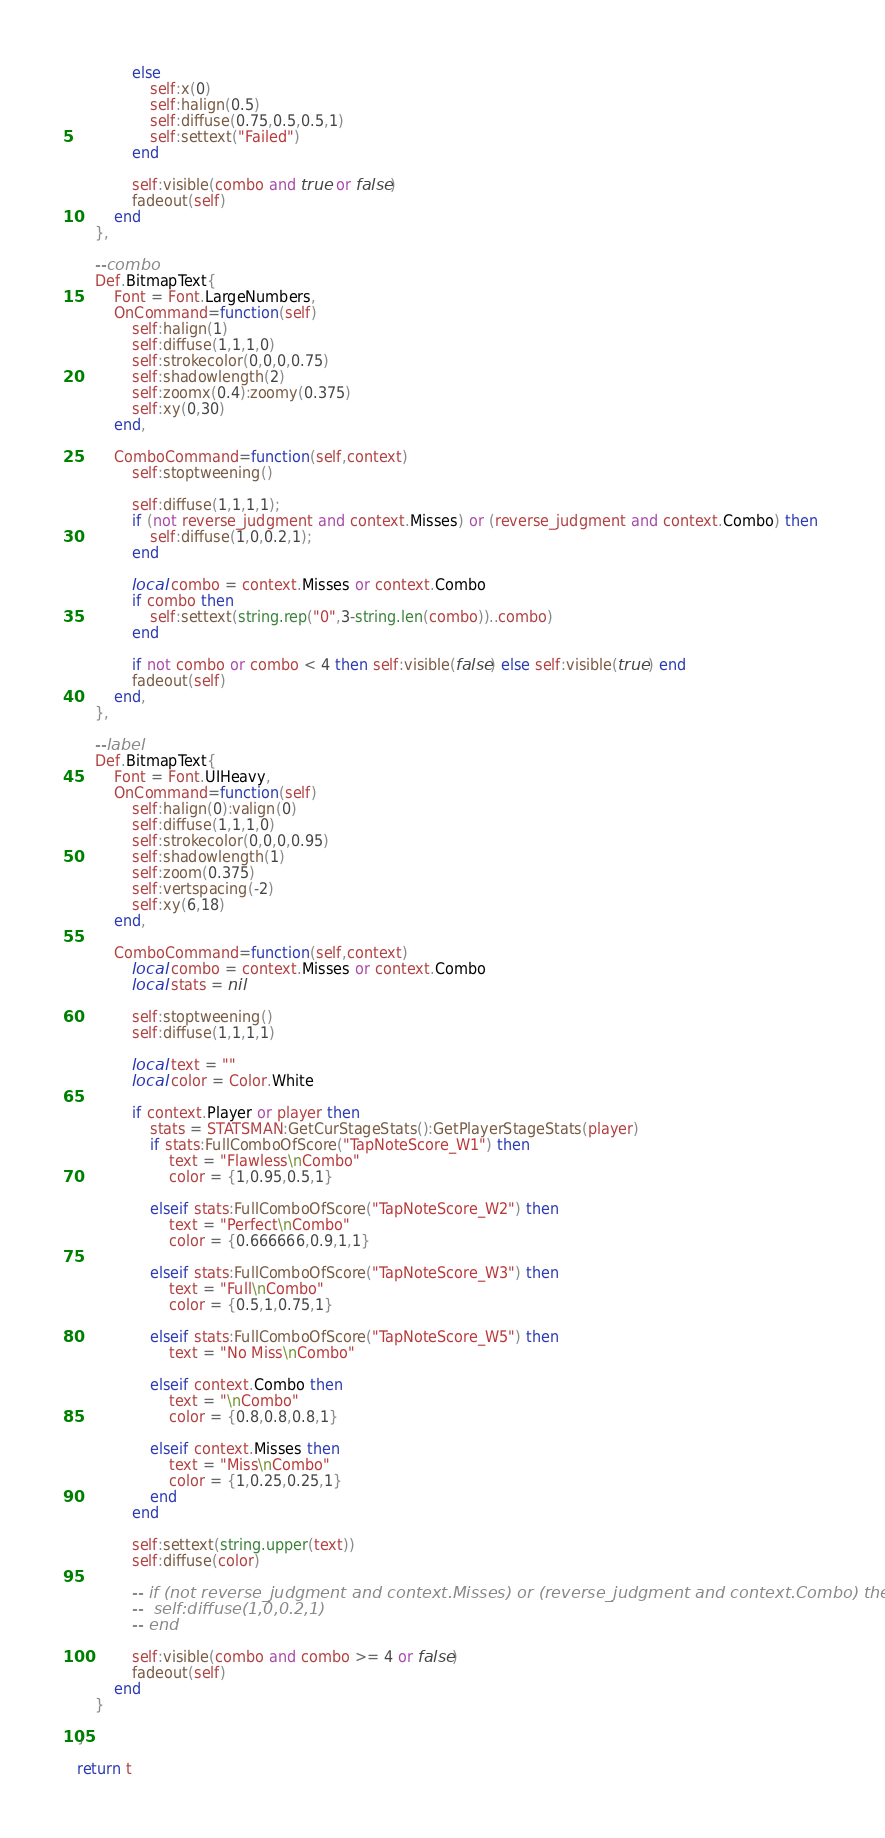<code> <loc_0><loc_0><loc_500><loc_500><_Lua_>            else
                self:x(0)
                self:halign(0.5)
                self:diffuse(0.75,0.5,0.5,1)
                self:settext("Failed")
            end

			self:visible(combo and true or false)
			fadeout(self)
		end
	},

	--combo
	Def.BitmapText{
		Font = Font.LargeNumbers,
		OnCommand=function(self)
			self:halign(1)
			self:diffuse(1,1,1,0)
			self:strokecolor(0,0,0,0.75)
			self:shadowlength(2)
			self:zoomx(0.4):zoomy(0.375)
			self:xy(0,30)
		end,

		ComboCommand=function(self,context)
			self:stoptweening()

			self:diffuse(1,1,1,1);
			if (not reverse_judgment and context.Misses) or (reverse_judgment and context.Combo) then
				self:diffuse(1,0,0.2,1);
			end

			local combo = context.Misses or context.Combo
			if combo then
				self:settext(string.rep("0",3-string.len(combo))..combo)
			end

			if not combo or combo < 4 then self:visible(false) else self:visible(true) end
			fadeout(self)
		end,
	},

	--label
	Def.BitmapText{
		Font = Font.UIHeavy,
		OnCommand=function(self)
			self:halign(0):valign(0)
			self:diffuse(1,1,1,0)
			self:strokecolor(0,0,0,0.95)
			self:shadowlength(1)
			self:zoom(0.375)
			self:vertspacing(-2)
			self:xy(6,18)
		end,

		ComboCommand=function(self,context)
			local combo = context.Misses or context.Combo
			local stats = nil

			self:stoptweening()
			self:diffuse(1,1,1,1)

            local text = ""
            local color = Color.White

			if context.Player or player then
				stats = STATSMAN:GetCurStageStats():GetPlayerStageStats(player)
				if stats:FullComboOfScore("TapNoteScore_W1") then
					text = "Flawless\nCombo"
                    color = {1,0.95,0.5,1}
                    
				elseif stats:FullComboOfScore("TapNoteScore_W2") then
					text = "Perfect\nCombo"
                    color = {0.666666,0.9,1,1}
                    
				elseif stats:FullComboOfScore("TapNoteScore_W3") then
					text = "Full\nCombo"
                    color = {0.5,1,0.75,1}
                    
				elseif stats:FullComboOfScore("TapNoteScore_W5") then
					text = "No Miss\nCombo"
                    
				elseif context.Combo then
					text = "\nCombo"
					color = {0.8,0.8,0.8,1}
                    
				elseif context.Misses then
					text = "Miss\nCombo"
                    color = {1,0.25,0.25,1}
				end
			end

            self:settext(string.upper(text))
            self:diffuse(color)

			-- if (not reverse_judgment and context.Misses) or (reverse_judgment and context.Combo) then
			-- 	self:diffuse(1,0,0.2,1)
			-- end

			self:visible(combo and combo >= 4 or false)
			fadeout(self)
		end
	}

}

return t</code> 